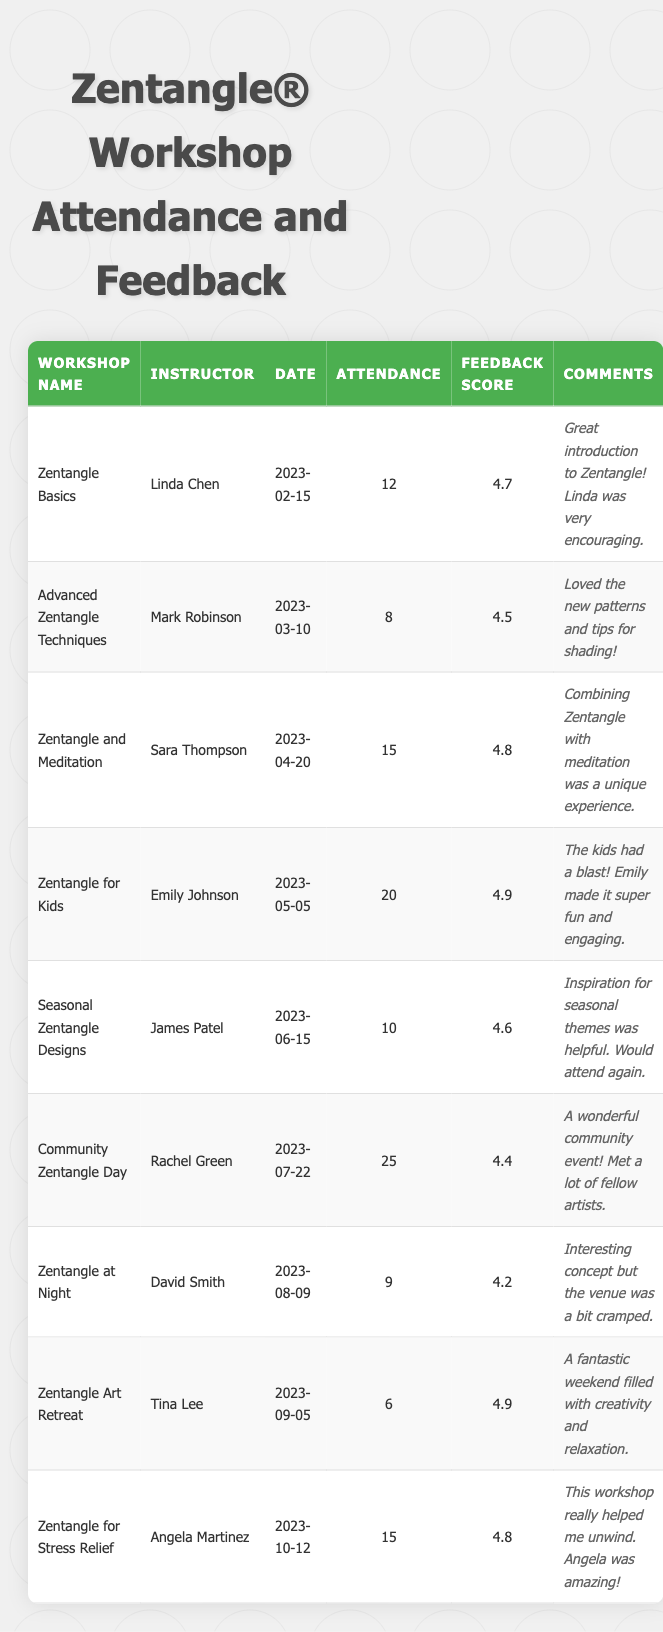What workshop had the highest attendance? By examining the Attendance column, the workshop "Zentangle for Kids" has the highest number with 20 participants.
Answer: Zentangle for Kids What is the average feedback score for all workshops? To find the average, we sum the feedback scores (4.7 + 4.5 + 4.8 + 4.9 + 4.6 + 4.4 + 4.2 + 4.9 + 4.8) which equals 39.8 and divide by the number of workshops (9), resulting in an average score of approximately 4.42.
Answer: 4.42 Was there any workshop where the feedback score was below 4.5? Checking the Feedback Score column, "Zentangle at Night" has a score of 4.2, which is below 4.5.
Answer: Yes Which workshop had the lowest attendance, and what was its feedback score? The "Zentangle Art Retreat" had the lowest attendance with 6 participants, and its feedback score was 4.9.
Answer: Zentangle Art Retreat, 4.9 How many workshops had attendance greater than 15? From the Attendance column, we see that "Zentangle for Kids" (20), "Community Zentangle Day" (25), and "Zentangle and Meditation" (15) meet this condition. Thus, there are 3 workshops with attendance greater than 15.
Answer: 3 What is the difference between the highest and lowest feedback scores? The highest feedback score is 4.9 (from "Zentangle for Kids" and "Zentangle Art Retreat") and the lowest is 4.2 (from "Zentangle at Night"). The difference is 4.9 - 4.2 = 0.7.
Answer: 0.7 Which instructor had the highest feedback score from their workshop? The highest feedback score is 4.9, and it was received by instructors Linda Chen ("Zentangle Basics") and Emily Johnson ("Zentangle for Kids").
Answer: Linda Chen and Emily Johnson Which workshop was conducted on the earliest date? The earliest date in the Date column is "2023-02-15," corresponding to the "Zentangle Basics" workshop.
Answer: Zentangle Basics How many comments mentioned fun or enjoyment? The comments for "Zentangle for Kids" and "Community Zentangle Day" directly mention fun, making a total of 2 workshops that highlighted enjoyment.
Answer: 2 Do more than half of the workshops have a feedback score of 4.5 or higher? There are 9 workshops, and 8 of them have feedback scores of 4.5 or higher (only "Zentangle at Night" has a score below). Thus, more than half do meet this criteria.
Answer: Yes 